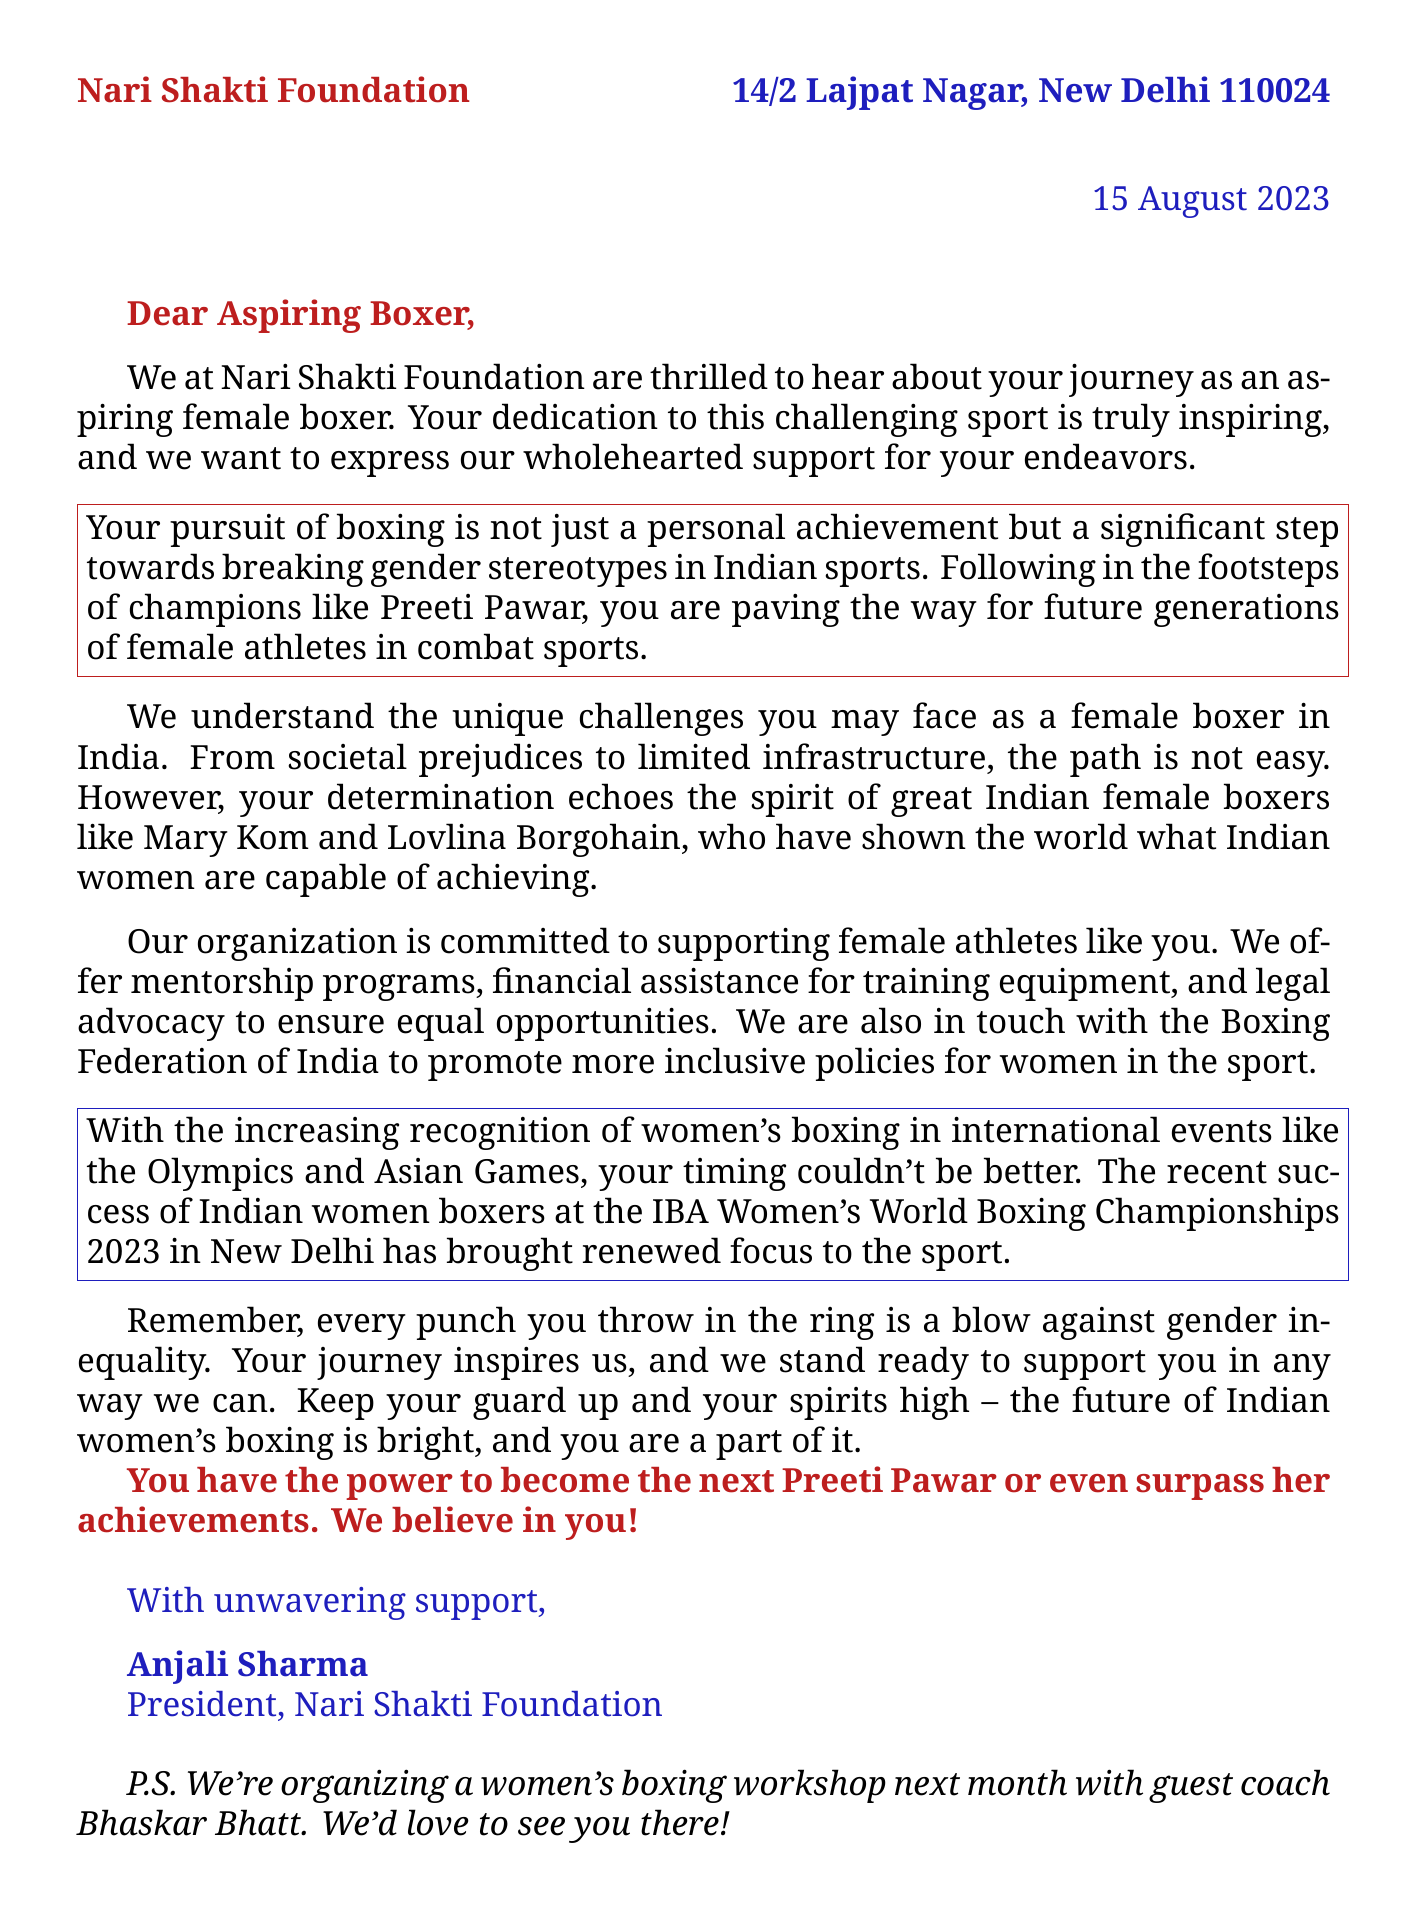what is the name of the organization? The name of the organization is mentioned at the top of the letter as Nari Shakti Foundation.
Answer: Nari Shakti Foundation when was the letter written? The date of the letter is clearly stated in the document as 15 August 2023.
Answer: 15 August 2023 who is the president of the organization? The closing of the letter provides the name of the president of the Nari Shakti Foundation as Anjali Sharma.
Answer: Anjali Sharma which female boxer is mentioned as an inspiration? The letter refers to Preeti Pawar as an inspirational figure for the aspiring boxer.
Answer: Preeti Pawar what kind of support does the organization offer? The letter outlines that the organization offers mentorship programs, financial assistance for training, and legal advocacy as support.
Answer: mentorship programs, financial assistance, legal advocacy what is the significance of the phrase "every punch you throw"? This phrase indicates that each action taken by the boxer contributes to fighting against gender inequality, highlighting a deeper meaning behind her sport.
Answer: a blow against gender inequality what event was successful for Indian women boxers recently? The document references the recent success of Indian women boxers at the IBA Women's World Boxing Championships 2023 in New Delhi.
Answer: IBA Women's World Boxing Championships 2023 what is the purpose of the P.S. at the end of the letter? The P.S. encourages attendance at a workshop and mentions a guest coach, indicating ongoing support and involvement.
Answer: organizing a women's boxing workshop how does the letter conclude? The letter concludes with an encouraging message about the future of Indian women's boxing and a reminder of the recipient's potential.
Answer: the future of Indian women's boxing is bright 